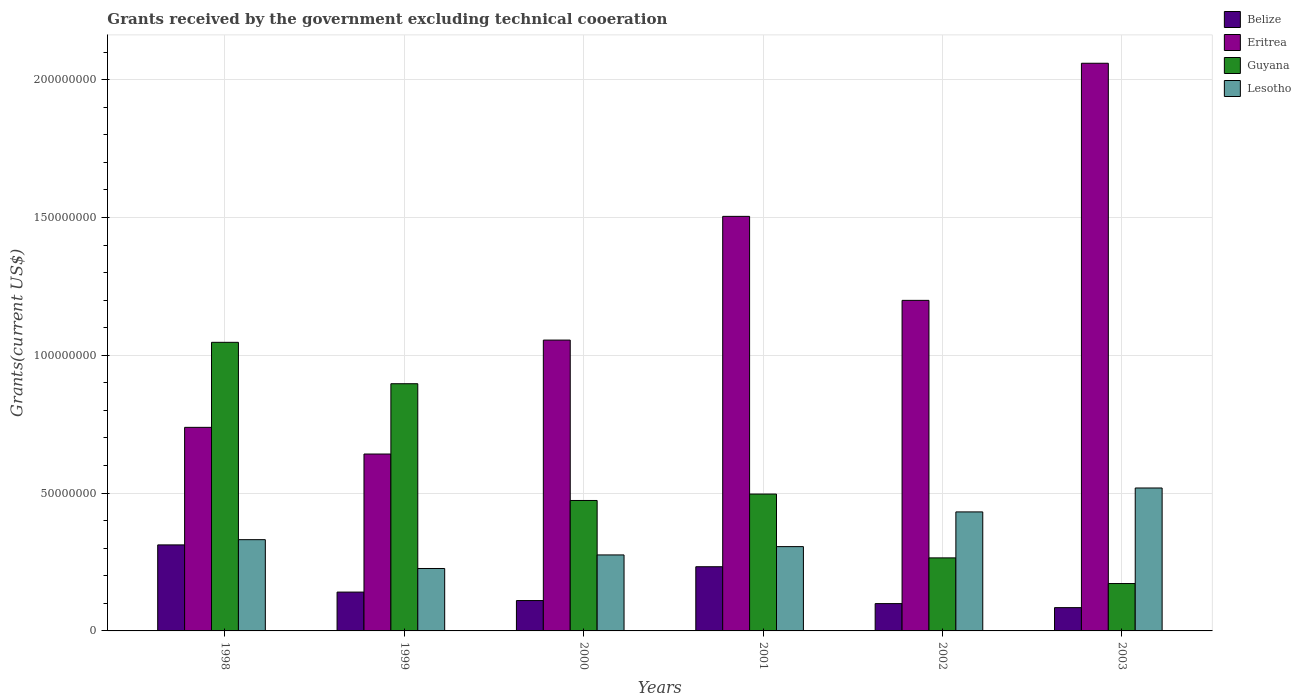Are the number of bars per tick equal to the number of legend labels?
Give a very brief answer. Yes. How many bars are there on the 5th tick from the left?
Make the answer very short. 4. What is the total grants received by the government in Eritrea in 1998?
Make the answer very short. 7.39e+07. Across all years, what is the maximum total grants received by the government in Lesotho?
Make the answer very short. 5.19e+07. Across all years, what is the minimum total grants received by the government in Belize?
Ensure brevity in your answer.  8.45e+06. In which year was the total grants received by the government in Guyana minimum?
Make the answer very short. 2003. What is the total total grants received by the government in Guyana in the graph?
Your response must be concise. 3.35e+08. What is the difference between the total grants received by the government in Belize in 2000 and that in 2002?
Make the answer very short. 1.11e+06. What is the difference between the total grants received by the government in Eritrea in 1998 and the total grants received by the government in Lesotho in 2002?
Your answer should be compact. 3.07e+07. What is the average total grants received by the government in Lesotho per year?
Keep it short and to the point. 3.48e+07. In the year 1998, what is the difference between the total grants received by the government in Guyana and total grants received by the government in Belize?
Keep it short and to the point. 7.35e+07. What is the ratio of the total grants received by the government in Belize in 2001 to that in 2003?
Keep it short and to the point. 2.76. Is the total grants received by the government in Belize in 2000 less than that in 2002?
Your answer should be very brief. No. Is the difference between the total grants received by the government in Guyana in 1999 and 2000 greater than the difference between the total grants received by the government in Belize in 1999 and 2000?
Keep it short and to the point. Yes. What is the difference between the highest and the second highest total grants received by the government in Guyana?
Offer a terse response. 1.50e+07. What is the difference between the highest and the lowest total grants received by the government in Lesotho?
Make the answer very short. 2.92e+07. What does the 3rd bar from the left in 1998 represents?
Offer a terse response. Guyana. What does the 2nd bar from the right in 2002 represents?
Offer a very short reply. Guyana. Are all the bars in the graph horizontal?
Keep it short and to the point. No. How many years are there in the graph?
Your answer should be very brief. 6. What is the difference between two consecutive major ticks on the Y-axis?
Your response must be concise. 5.00e+07. Does the graph contain any zero values?
Make the answer very short. No. How many legend labels are there?
Offer a very short reply. 4. How are the legend labels stacked?
Your answer should be compact. Vertical. What is the title of the graph?
Ensure brevity in your answer.  Grants received by the government excluding technical cooeration. What is the label or title of the X-axis?
Your answer should be very brief. Years. What is the label or title of the Y-axis?
Give a very brief answer. Grants(current US$). What is the Grants(current US$) in Belize in 1998?
Your answer should be compact. 3.12e+07. What is the Grants(current US$) in Eritrea in 1998?
Your response must be concise. 7.39e+07. What is the Grants(current US$) of Guyana in 1998?
Ensure brevity in your answer.  1.05e+08. What is the Grants(current US$) of Lesotho in 1998?
Offer a terse response. 3.31e+07. What is the Grants(current US$) in Belize in 1999?
Offer a very short reply. 1.41e+07. What is the Grants(current US$) in Eritrea in 1999?
Your response must be concise. 6.42e+07. What is the Grants(current US$) of Guyana in 1999?
Offer a terse response. 8.97e+07. What is the Grants(current US$) of Lesotho in 1999?
Keep it short and to the point. 2.26e+07. What is the Grants(current US$) of Belize in 2000?
Make the answer very short. 1.10e+07. What is the Grants(current US$) of Eritrea in 2000?
Your answer should be very brief. 1.06e+08. What is the Grants(current US$) in Guyana in 2000?
Give a very brief answer. 4.73e+07. What is the Grants(current US$) of Lesotho in 2000?
Offer a very short reply. 2.76e+07. What is the Grants(current US$) in Belize in 2001?
Give a very brief answer. 2.33e+07. What is the Grants(current US$) in Eritrea in 2001?
Provide a short and direct response. 1.50e+08. What is the Grants(current US$) of Guyana in 2001?
Give a very brief answer. 4.97e+07. What is the Grants(current US$) in Lesotho in 2001?
Give a very brief answer. 3.06e+07. What is the Grants(current US$) in Belize in 2002?
Provide a short and direct response. 9.91e+06. What is the Grants(current US$) in Eritrea in 2002?
Provide a succinct answer. 1.20e+08. What is the Grants(current US$) in Guyana in 2002?
Your response must be concise. 2.65e+07. What is the Grants(current US$) of Lesotho in 2002?
Offer a terse response. 4.32e+07. What is the Grants(current US$) of Belize in 2003?
Your answer should be very brief. 8.45e+06. What is the Grants(current US$) of Eritrea in 2003?
Provide a succinct answer. 2.06e+08. What is the Grants(current US$) in Guyana in 2003?
Your answer should be compact. 1.72e+07. What is the Grants(current US$) of Lesotho in 2003?
Make the answer very short. 5.19e+07. Across all years, what is the maximum Grants(current US$) of Belize?
Offer a terse response. 3.12e+07. Across all years, what is the maximum Grants(current US$) in Eritrea?
Give a very brief answer. 2.06e+08. Across all years, what is the maximum Grants(current US$) in Guyana?
Ensure brevity in your answer.  1.05e+08. Across all years, what is the maximum Grants(current US$) of Lesotho?
Ensure brevity in your answer.  5.19e+07. Across all years, what is the minimum Grants(current US$) in Belize?
Give a very brief answer. 8.45e+06. Across all years, what is the minimum Grants(current US$) of Eritrea?
Your response must be concise. 6.42e+07. Across all years, what is the minimum Grants(current US$) of Guyana?
Give a very brief answer. 1.72e+07. Across all years, what is the minimum Grants(current US$) in Lesotho?
Provide a short and direct response. 2.26e+07. What is the total Grants(current US$) of Belize in the graph?
Your answer should be very brief. 9.80e+07. What is the total Grants(current US$) in Eritrea in the graph?
Your answer should be compact. 7.20e+08. What is the total Grants(current US$) in Guyana in the graph?
Keep it short and to the point. 3.35e+08. What is the total Grants(current US$) in Lesotho in the graph?
Offer a very short reply. 2.09e+08. What is the difference between the Grants(current US$) in Belize in 1998 and that in 1999?
Make the answer very short. 1.71e+07. What is the difference between the Grants(current US$) of Eritrea in 1998 and that in 1999?
Make the answer very short. 9.68e+06. What is the difference between the Grants(current US$) in Guyana in 1998 and that in 1999?
Provide a succinct answer. 1.50e+07. What is the difference between the Grants(current US$) in Lesotho in 1998 and that in 1999?
Keep it short and to the point. 1.05e+07. What is the difference between the Grants(current US$) in Belize in 1998 and that in 2000?
Provide a succinct answer. 2.02e+07. What is the difference between the Grants(current US$) of Eritrea in 1998 and that in 2000?
Provide a succinct answer. -3.17e+07. What is the difference between the Grants(current US$) in Guyana in 1998 and that in 2000?
Give a very brief answer. 5.74e+07. What is the difference between the Grants(current US$) of Lesotho in 1998 and that in 2000?
Offer a very short reply. 5.54e+06. What is the difference between the Grants(current US$) in Belize in 1998 and that in 2001?
Offer a very short reply. 7.92e+06. What is the difference between the Grants(current US$) in Eritrea in 1998 and that in 2001?
Provide a succinct answer. -7.66e+07. What is the difference between the Grants(current US$) in Guyana in 1998 and that in 2001?
Ensure brevity in your answer.  5.50e+07. What is the difference between the Grants(current US$) of Lesotho in 1998 and that in 2001?
Your response must be concise. 2.52e+06. What is the difference between the Grants(current US$) in Belize in 1998 and that in 2002?
Offer a very short reply. 2.13e+07. What is the difference between the Grants(current US$) of Eritrea in 1998 and that in 2002?
Offer a very short reply. -4.61e+07. What is the difference between the Grants(current US$) in Guyana in 1998 and that in 2002?
Your answer should be compact. 7.82e+07. What is the difference between the Grants(current US$) of Lesotho in 1998 and that in 2002?
Keep it short and to the point. -1.01e+07. What is the difference between the Grants(current US$) in Belize in 1998 and that in 2003?
Give a very brief answer. 2.28e+07. What is the difference between the Grants(current US$) in Eritrea in 1998 and that in 2003?
Provide a succinct answer. -1.32e+08. What is the difference between the Grants(current US$) in Guyana in 1998 and that in 2003?
Ensure brevity in your answer.  8.75e+07. What is the difference between the Grants(current US$) in Lesotho in 1998 and that in 2003?
Offer a very short reply. -1.88e+07. What is the difference between the Grants(current US$) of Belize in 1999 and that in 2000?
Provide a succinct answer. 3.07e+06. What is the difference between the Grants(current US$) in Eritrea in 1999 and that in 2000?
Provide a succinct answer. -4.13e+07. What is the difference between the Grants(current US$) of Guyana in 1999 and that in 2000?
Give a very brief answer. 4.24e+07. What is the difference between the Grants(current US$) in Lesotho in 1999 and that in 2000?
Offer a very short reply. -4.92e+06. What is the difference between the Grants(current US$) of Belize in 1999 and that in 2001?
Offer a very short reply. -9.20e+06. What is the difference between the Grants(current US$) in Eritrea in 1999 and that in 2001?
Keep it short and to the point. -8.62e+07. What is the difference between the Grants(current US$) in Guyana in 1999 and that in 2001?
Offer a terse response. 4.00e+07. What is the difference between the Grants(current US$) of Lesotho in 1999 and that in 2001?
Give a very brief answer. -7.94e+06. What is the difference between the Grants(current US$) in Belize in 1999 and that in 2002?
Keep it short and to the point. 4.18e+06. What is the difference between the Grants(current US$) in Eritrea in 1999 and that in 2002?
Make the answer very short. -5.58e+07. What is the difference between the Grants(current US$) of Guyana in 1999 and that in 2002?
Provide a short and direct response. 6.32e+07. What is the difference between the Grants(current US$) in Lesotho in 1999 and that in 2002?
Ensure brevity in your answer.  -2.05e+07. What is the difference between the Grants(current US$) of Belize in 1999 and that in 2003?
Give a very brief answer. 5.64e+06. What is the difference between the Grants(current US$) of Eritrea in 1999 and that in 2003?
Keep it short and to the point. -1.42e+08. What is the difference between the Grants(current US$) in Guyana in 1999 and that in 2003?
Keep it short and to the point. 7.25e+07. What is the difference between the Grants(current US$) of Lesotho in 1999 and that in 2003?
Give a very brief answer. -2.92e+07. What is the difference between the Grants(current US$) in Belize in 2000 and that in 2001?
Make the answer very short. -1.23e+07. What is the difference between the Grants(current US$) in Eritrea in 2000 and that in 2001?
Offer a terse response. -4.49e+07. What is the difference between the Grants(current US$) of Guyana in 2000 and that in 2001?
Keep it short and to the point. -2.33e+06. What is the difference between the Grants(current US$) of Lesotho in 2000 and that in 2001?
Offer a terse response. -3.02e+06. What is the difference between the Grants(current US$) of Belize in 2000 and that in 2002?
Make the answer very short. 1.11e+06. What is the difference between the Grants(current US$) of Eritrea in 2000 and that in 2002?
Provide a short and direct response. -1.44e+07. What is the difference between the Grants(current US$) in Guyana in 2000 and that in 2002?
Your response must be concise. 2.08e+07. What is the difference between the Grants(current US$) of Lesotho in 2000 and that in 2002?
Keep it short and to the point. -1.56e+07. What is the difference between the Grants(current US$) in Belize in 2000 and that in 2003?
Provide a short and direct response. 2.57e+06. What is the difference between the Grants(current US$) of Eritrea in 2000 and that in 2003?
Give a very brief answer. -1.00e+08. What is the difference between the Grants(current US$) in Guyana in 2000 and that in 2003?
Your response must be concise. 3.01e+07. What is the difference between the Grants(current US$) in Lesotho in 2000 and that in 2003?
Your answer should be compact. -2.43e+07. What is the difference between the Grants(current US$) of Belize in 2001 and that in 2002?
Ensure brevity in your answer.  1.34e+07. What is the difference between the Grants(current US$) of Eritrea in 2001 and that in 2002?
Make the answer very short. 3.05e+07. What is the difference between the Grants(current US$) in Guyana in 2001 and that in 2002?
Ensure brevity in your answer.  2.32e+07. What is the difference between the Grants(current US$) in Lesotho in 2001 and that in 2002?
Provide a short and direct response. -1.26e+07. What is the difference between the Grants(current US$) in Belize in 2001 and that in 2003?
Make the answer very short. 1.48e+07. What is the difference between the Grants(current US$) in Eritrea in 2001 and that in 2003?
Your response must be concise. -5.56e+07. What is the difference between the Grants(current US$) of Guyana in 2001 and that in 2003?
Ensure brevity in your answer.  3.25e+07. What is the difference between the Grants(current US$) of Lesotho in 2001 and that in 2003?
Give a very brief answer. -2.13e+07. What is the difference between the Grants(current US$) of Belize in 2002 and that in 2003?
Your answer should be very brief. 1.46e+06. What is the difference between the Grants(current US$) of Eritrea in 2002 and that in 2003?
Your answer should be compact. -8.60e+07. What is the difference between the Grants(current US$) in Guyana in 2002 and that in 2003?
Your response must be concise. 9.31e+06. What is the difference between the Grants(current US$) of Lesotho in 2002 and that in 2003?
Keep it short and to the point. -8.68e+06. What is the difference between the Grants(current US$) in Belize in 1998 and the Grants(current US$) in Eritrea in 1999?
Your answer should be compact. -3.30e+07. What is the difference between the Grants(current US$) of Belize in 1998 and the Grants(current US$) of Guyana in 1999?
Offer a very short reply. -5.85e+07. What is the difference between the Grants(current US$) of Belize in 1998 and the Grants(current US$) of Lesotho in 1999?
Your response must be concise. 8.56e+06. What is the difference between the Grants(current US$) of Eritrea in 1998 and the Grants(current US$) of Guyana in 1999?
Your answer should be very brief. -1.58e+07. What is the difference between the Grants(current US$) of Eritrea in 1998 and the Grants(current US$) of Lesotho in 1999?
Keep it short and to the point. 5.12e+07. What is the difference between the Grants(current US$) of Guyana in 1998 and the Grants(current US$) of Lesotho in 1999?
Ensure brevity in your answer.  8.21e+07. What is the difference between the Grants(current US$) in Belize in 1998 and the Grants(current US$) in Eritrea in 2000?
Provide a succinct answer. -7.43e+07. What is the difference between the Grants(current US$) in Belize in 1998 and the Grants(current US$) in Guyana in 2000?
Provide a succinct answer. -1.61e+07. What is the difference between the Grants(current US$) in Belize in 1998 and the Grants(current US$) in Lesotho in 2000?
Make the answer very short. 3.64e+06. What is the difference between the Grants(current US$) of Eritrea in 1998 and the Grants(current US$) of Guyana in 2000?
Your response must be concise. 2.65e+07. What is the difference between the Grants(current US$) in Eritrea in 1998 and the Grants(current US$) in Lesotho in 2000?
Provide a succinct answer. 4.63e+07. What is the difference between the Grants(current US$) of Guyana in 1998 and the Grants(current US$) of Lesotho in 2000?
Offer a terse response. 7.71e+07. What is the difference between the Grants(current US$) of Belize in 1998 and the Grants(current US$) of Eritrea in 2001?
Provide a short and direct response. -1.19e+08. What is the difference between the Grants(current US$) in Belize in 1998 and the Grants(current US$) in Guyana in 2001?
Give a very brief answer. -1.84e+07. What is the difference between the Grants(current US$) in Belize in 1998 and the Grants(current US$) in Lesotho in 2001?
Provide a succinct answer. 6.20e+05. What is the difference between the Grants(current US$) in Eritrea in 1998 and the Grants(current US$) in Guyana in 2001?
Provide a succinct answer. 2.42e+07. What is the difference between the Grants(current US$) of Eritrea in 1998 and the Grants(current US$) of Lesotho in 2001?
Give a very brief answer. 4.33e+07. What is the difference between the Grants(current US$) in Guyana in 1998 and the Grants(current US$) in Lesotho in 2001?
Provide a short and direct response. 7.41e+07. What is the difference between the Grants(current US$) in Belize in 1998 and the Grants(current US$) in Eritrea in 2002?
Keep it short and to the point. -8.87e+07. What is the difference between the Grants(current US$) in Belize in 1998 and the Grants(current US$) in Guyana in 2002?
Your answer should be very brief. 4.71e+06. What is the difference between the Grants(current US$) of Belize in 1998 and the Grants(current US$) of Lesotho in 2002?
Your answer should be compact. -1.20e+07. What is the difference between the Grants(current US$) in Eritrea in 1998 and the Grants(current US$) in Guyana in 2002?
Keep it short and to the point. 4.74e+07. What is the difference between the Grants(current US$) of Eritrea in 1998 and the Grants(current US$) of Lesotho in 2002?
Provide a succinct answer. 3.07e+07. What is the difference between the Grants(current US$) in Guyana in 1998 and the Grants(current US$) in Lesotho in 2002?
Your response must be concise. 6.15e+07. What is the difference between the Grants(current US$) in Belize in 1998 and the Grants(current US$) in Eritrea in 2003?
Keep it short and to the point. -1.75e+08. What is the difference between the Grants(current US$) of Belize in 1998 and the Grants(current US$) of Guyana in 2003?
Make the answer very short. 1.40e+07. What is the difference between the Grants(current US$) in Belize in 1998 and the Grants(current US$) in Lesotho in 2003?
Your answer should be very brief. -2.06e+07. What is the difference between the Grants(current US$) in Eritrea in 1998 and the Grants(current US$) in Guyana in 2003?
Offer a very short reply. 5.67e+07. What is the difference between the Grants(current US$) in Eritrea in 1998 and the Grants(current US$) in Lesotho in 2003?
Make the answer very short. 2.20e+07. What is the difference between the Grants(current US$) of Guyana in 1998 and the Grants(current US$) of Lesotho in 2003?
Your answer should be compact. 5.28e+07. What is the difference between the Grants(current US$) in Belize in 1999 and the Grants(current US$) in Eritrea in 2000?
Your answer should be compact. -9.14e+07. What is the difference between the Grants(current US$) of Belize in 1999 and the Grants(current US$) of Guyana in 2000?
Ensure brevity in your answer.  -3.32e+07. What is the difference between the Grants(current US$) in Belize in 1999 and the Grants(current US$) in Lesotho in 2000?
Offer a terse response. -1.35e+07. What is the difference between the Grants(current US$) in Eritrea in 1999 and the Grants(current US$) in Guyana in 2000?
Your answer should be very brief. 1.68e+07. What is the difference between the Grants(current US$) of Eritrea in 1999 and the Grants(current US$) of Lesotho in 2000?
Provide a succinct answer. 3.66e+07. What is the difference between the Grants(current US$) of Guyana in 1999 and the Grants(current US$) of Lesotho in 2000?
Your answer should be compact. 6.21e+07. What is the difference between the Grants(current US$) of Belize in 1999 and the Grants(current US$) of Eritrea in 2001?
Provide a short and direct response. -1.36e+08. What is the difference between the Grants(current US$) in Belize in 1999 and the Grants(current US$) in Guyana in 2001?
Your answer should be compact. -3.56e+07. What is the difference between the Grants(current US$) in Belize in 1999 and the Grants(current US$) in Lesotho in 2001?
Offer a terse response. -1.65e+07. What is the difference between the Grants(current US$) of Eritrea in 1999 and the Grants(current US$) of Guyana in 2001?
Provide a short and direct response. 1.45e+07. What is the difference between the Grants(current US$) of Eritrea in 1999 and the Grants(current US$) of Lesotho in 2001?
Provide a succinct answer. 3.36e+07. What is the difference between the Grants(current US$) in Guyana in 1999 and the Grants(current US$) in Lesotho in 2001?
Offer a terse response. 5.91e+07. What is the difference between the Grants(current US$) in Belize in 1999 and the Grants(current US$) in Eritrea in 2002?
Provide a short and direct response. -1.06e+08. What is the difference between the Grants(current US$) in Belize in 1999 and the Grants(current US$) in Guyana in 2002?
Provide a short and direct response. -1.24e+07. What is the difference between the Grants(current US$) in Belize in 1999 and the Grants(current US$) in Lesotho in 2002?
Give a very brief answer. -2.91e+07. What is the difference between the Grants(current US$) of Eritrea in 1999 and the Grants(current US$) of Guyana in 2002?
Provide a succinct answer. 3.77e+07. What is the difference between the Grants(current US$) in Eritrea in 1999 and the Grants(current US$) in Lesotho in 2002?
Keep it short and to the point. 2.10e+07. What is the difference between the Grants(current US$) in Guyana in 1999 and the Grants(current US$) in Lesotho in 2002?
Keep it short and to the point. 4.65e+07. What is the difference between the Grants(current US$) of Belize in 1999 and the Grants(current US$) of Eritrea in 2003?
Keep it short and to the point. -1.92e+08. What is the difference between the Grants(current US$) in Belize in 1999 and the Grants(current US$) in Guyana in 2003?
Keep it short and to the point. -3.10e+06. What is the difference between the Grants(current US$) in Belize in 1999 and the Grants(current US$) in Lesotho in 2003?
Give a very brief answer. -3.78e+07. What is the difference between the Grants(current US$) of Eritrea in 1999 and the Grants(current US$) of Guyana in 2003?
Provide a succinct answer. 4.70e+07. What is the difference between the Grants(current US$) of Eritrea in 1999 and the Grants(current US$) of Lesotho in 2003?
Keep it short and to the point. 1.23e+07. What is the difference between the Grants(current US$) of Guyana in 1999 and the Grants(current US$) of Lesotho in 2003?
Your response must be concise. 3.78e+07. What is the difference between the Grants(current US$) in Belize in 2000 and the Grants(current US$) in Eritrea in 2001?
Your answer should be compact. -1.39e+08. What is the difference between the Grants(current US$) in Belize in 2000 and the Grants(current US$) in Guyana in 2001?
Make the answer very short. -3.86e+07. What is the difference between the Grants(current US$) in Belize in 2000 and the Grants(current US$) in Lesotho in 2001?
Ensure brevity in your answer.  -1.96e+07. What is the difference between the Grants(current US$) in Eritrea in 2000 and the Grants(current US$) in Guyana in 2001?
Offer a terse response. 5.59e+07. What is the difference between the Grants(current US$) of Eritrea in 2000 and the Grants(current US$) of Lesotho in 2001?
Provide a short and direct response. 7.49e+07. What is the difference between the Grants(current US$) of Guyana in 2000 and the Grants(current US$) of Lesotho in 2001?
Offer a very short reply. 1.67e+07. What is the difference between the Grants(current US$) in Belize in 2000 and the Grants(current US$) in Eritrea in 2002?
Provide a succinct answer. -1.09e+08. What is the difference between the Grants(current US$) in Belize in 2000 and the Grants(current US$) in Guyana in 2002?
Your response must be concise. -1.55e+07. What is the difference between the Grants(current US$) of Belize in 2000 and the Grants(current US$) of Lesotho in 2002?
Provide a short and direct response. -3.22e+07. What is the difference between the Grants(current US$) in Eritrea in 2000 and the Grants(current US$) in Guyana in 2002?
Provide a succinct answer. 7.90e+07. What is the difference between the Grants(current US$) of Eritrea in 2000 and the Grants(current US$) of Lesotho in 2002?
Offer a very short reply. 6.23e+07. What is the difference between the Grants(current US$) in Guyana in 2000 and the Grants(current US$) in Lesotho in 2002?
Keep it short and to the point. 4.15e+06. What is the difference between the Grants(current US$) in Belize in 2000 and the Grants(current US$) in Eritrea in 2003?
Offer a terse response. -1.95e+08. What is the difference between the Grants(current US$) in Belize in 2000 and the Grants(current US$) in Guyana in 2003?
Ensure brevity in your answer.  -6.17e+06. What is the difference between the Grants(current US$) in Belize in 2000 and the Grants(current US$) in Lesotho in 2003?
Offer a very short reply. -4.08e+07. What is the difference between the Grants(current US$) of Eritrea in 2000 and the Grants(current US$) of Guyana in 2003?
Provide a succinct answer. 8.83e+07. What is the difference between the Grants(current US$) of Eritrea in 2000 and the Grants(current US$) of Lesotho in 2003?
Provide a succinct answer. 5.37e+07. What is the difference between the Grants(current US$) of Guyana in 2000 and the Grants(current US$) of Lesotho in 2003?
Offer a very short reply. -4.53e+06. What is the difference between the Grants(current US$) in Belize in 2001 and the Grants(current US$) in Eritrea in 2002?
Provide a succinct answer. -9.66e+07. What is the difference between the Grants(current US$) in Belize in 2001 and the Grants(current US$) in Guyana in 2002?
Ensure brevity in your answer.  -3.21e+06. What is the difference between the Grants(current US$) in Belize in 2001 and the Grants(current US$) in Lesotho in 2002?
Offer a terse response. -1.99e+07. What is the difference between the Grants(current US$) in Eritrea in 2001 and the Grants(current US$) in Guyana in 2002?
Ensure brevity in your answer.  1.24e+08. What is the difference between the Grants(current US$) in Eritrea in 2001 and the Grants(current US$) in Lesotho in 2002?
Offer a very short reply. 1.07e+08. What is the difference between the Grants(current US$) in Guyana in 2001 and the Grants(current US$) in Lesotho in 2002?
Your answer should be very brief. 6.48e+06. What is the difference between the Grants(current US$) of Belize in 2001 and the Grants(current US$) of Eritrea in 2003?
Your answer should be compact. -1.83e+08. What is the difference between the Grants(current US$) of Belize in 2001 and the Grants(current US$) of Guyana in 2003?
Give a very brief answer. 6.10e+06. What is the difference between the Grants(current US$) in Belize in 2001 and the Grants(current US$) in Lesotho in 2003?
Make the answer very short. -2.86e+07. What is the difference between the Grants(current US$) in Eritrea in 2001 and the Grants(current US$) in Guyana in 2003?
Offer a very short reply. 1.33e+08. What is the difference between the Grants(current US$) of Eritrea in 2001 and the Grants(current US$) of Lesotho in 2003?
Ensure brevity in your answer.  9.86e+07. What is the difference between the Grants(current US$) in Guyana in 2001 and the Grants(current US$) in Lesotho in 2003?
Provide a succinct answer. -2.20e+06. What is the difference between the Grants(current US$) in Belize in 2002 and the Grants(current US$) in Eritrea in 2003?
Your answer should be very brief. -1.96e+08. What is the difference between the Grants(current US$) in Belize in 2002 and the Grants(current US$) in Guyana in 2003?
Provide a succinct answer. -7.28e+06. What is the difference between the Grants(current US$) of Belize in 2002 and the Grants(current US$) of Lesotho in 2003?
Offer a very short reply. -4.20e+07. What is the difference between the Grants(current US$) in Eritrea in 2002 and the Grants(current US$) in Guyana in 2003?
Offer a very short reply. 1.03e+08. What is the difference between the Grants(current US$) in Eritrea in 2002 and the Grants(current US$) in Lesotho in 2003?
Your answer should be very brief. 6.81e+07. What is the difference between the Grants(current US$) in Guyana in 2002 and the Grants(current US$) in Lesotho in 2003?
Your response must be concise. -2.54e+07. What is the average Grants(current US$) in Belize per year?
Give a very brief answer. 1.63e+07. What is the average Grants(current US$) of Eritrea per year?
Keep it short and to the point. 1.20e+08. What is the average Grants(current US$) of Guyana per year?
Your response must be concise. 5.58e+07. What is the average Grants(current US$) of Lesotho per year?
Your answer should be very brief. 3.48e+07. In the year 1998, what is the difference between the Grants(current US$) of Belize and Grants(current US$) of Eritrea?
Give a very brief answer. -4.26e+07. In the year 1998, what is the difference between the Grants(current US$) of Belize and Grants(current US$) of Guyana?
Your response must be concise. -7.35e+07. In the year 1998, what is the difference between the Grants(current US$) of Belize and Grants(current US$) of Lesotho?
Offer a very short reply. -1.90e+06. In the year 1998, what is the difference between the Grants(current US$) in Eritrea and Grants(current US$) in Guyana?
Your answer should be very brief. -3.08e+07. In the year 1998, what is the difference between the Grants(current US$) of Eritrea and Grants(current US$) of Lesotho?
Provide a short and direct response. 4.08e+07. In the year 1998, what is the difference between the Grants(current US$) of Guyana and Grants(current US$) of Lesotho?
Your answer should be compact. 7.16e+07. In the year 1999, what is the difference between the Grants(current US$) of Belize and Grants(current US$) of Eritrea?
Your response must be concise. -5.01e+07. In the year 1999, what is the difference between the Grants(current US$) in Belize and Grants(current US$) in Guyana?
Keep it short and to the point. -7.56e+07. In the year 1999, what is the difference between the Grants(current US$) of Belize and Grants(current US$) of Lesotho?
Ensure brevity in your answer.  -8.56e+06. In the year 1999, what is the difference between the Grants(current US$) in Eritrea and Grants(current US$) in Guyana?
Make the answer very short. -2.55e+07. In the year 1999, what is the difference between the Grants(current US$) of Eritrea and Grants(current US$) of Lesotho?
Make the answer very short. 4.15e+07. In the year 1999, what is the difference between the Grants(current US$) in Guyana and Grants(current US$) in Lesotho?
Give a very brief answer. 6.70e+07. In the year 2000, what is the difference between the Grants(current US$) of Belize and Grants(current US$) of Eritrea?
Ensure brevity in your answer.  -9.45e+07. In the year 2000, what is the difference between the Grants(current US$) in Belize and Grants(current US$) in Guyana?
Offer a very short reply. -3.63e+07. In the year 2000, what is the difference between the Grants(current US$) in Belize and Grants(current US$) in Lesotho?
Make the answer very short. -1.66e+07. In the year 2000, what is the difference between the Grants(current US$) of Eritrea and Grants(current US$) of Guyana?
Ensure brevity in your answer.  5.82e+07. In the year 2000, what is the difference between the Grants(current US$) of Eritrea and Grants(current US$) of Lesotho?
Provide a succinct answer. 7.80e+07. In the year 2000, what is the difference between the Grants(current US$) in Guyana and Grants(current US$) in Lesotho?
Provide a succinct answer. 1.98e+07. In the year 2001, what is the difference between the Grants(current US$) in Belize and Grants(current US$) in Eritrea?
Give a very brief answer. -1.27e+08. In the year 2001, what is the difference between the Grants(current US$) of Belize and Grants(current US$) of Guyana?
Your answer should be compact. -2.64e+07. In the year 2001, what is the difference between the Grants(current US$) of Belize and Grants(current US$) of Lesotho?
Make the answer very short. -7.30e+06. In the year 2001, what is the difference between the Grants(current US$) in Eritrea and Grants(current US$) in Guyana?
Make the answer very short. 1.01e+08. In the year 2001, what is the difference between the Grants(current US$) in Eritrea and Grants(current US$) in Lesotho?
Provide a short and direct response. 1.20e+08. In the year 2001, what is the difference between the Grants(current US$) in Guyana and Grants(current US$) in Lesotho?
Provide a short and direct response. 1.91e+07. In the year 2002, what is the difference between the Grants(current US$) in Belize and Grants(current US$) in Eritrea?
Provide a short and direct response. -1.10e+08. In the year 2002, what is the difference between the Grants(current US$) of Belize and Grants(current US$) of Guyana?
Provide a succinct answer. -1.66e+07. In the year 2002, what is the difference between the Grants(current US$) in Belize and Grants(current US$) in Lesotho?
Your response must be concise. -3.33e+07. In the year 2002, what is the difference between the Grants(current US$) in Eritrea and Grants(current US$) in Guyana?
Provide a short and direct response. 9.34e+07. In the year 2002, what is the difference between the Grants(current US$) in Eritrea and Grants(current US$) in Lesotho?
Your response must be concise. 7.68e+07. In the year 2002, what is the difference between the Grants(current US$) of Guyana and Grants(current US$) of Lesotho?
Provide a succinct answer. -1.67e+07. In the year 2003, what is the difference between the Grants(current US$) of Belize and Grants(current US$) of Eritrea?
Provide a short and direct response. -1.98e+08. In the year 2003, what is the difference between the Grants(current US$) in Belize and Grants(current US$) in Guyana?
Make the answer very short. -8.74e+06. In the year 2003, what is the difference between the Grants(current US$) of Belize and Grants(current US$) of Lesotho?
Provide a succinct answer. -4.34e+07. In the year 2003, what is the difference between the Grants(current US$) of Eritrea and Grants(current US$) of Guyana?
Give a very brief answer. 1.89e+08. In the year 2003, what is the difference between the Grants(current US$) of Eritrea and Grants(current US$) of Lesotho?
Your answer should be very brief. 1.54e+08. In the year 2003, what is the difference between the Grants(current US$) in Guyana and Grants(current US$) in Lesotho?
Provide a succinct answer. -3.47e+07. What is the ratio of the Grants(current US$) of Belize in 1998 to that in 1999?
Make the answer very short. 2.21. What is the ratio of the Grants(current US$) in Eritrea in 1998 to that in 1999?
Offer a very short reply. 1.15. What is the ratio of the Grants(current US$) of Guyana in 1998 to that in 1999?
Keep it short and to the point. 1.17. What is the ratio of the Grants(current US$) of Lesotho in 1998 to that in 1999?
Provide a short and direct response. 1.46. What is the ratio of the Grants(current US$) in Belize in 1998 to that in 2000?
Keep it short and to the point. 2.83. What is the ratio of the Grants(current US$) in Guyana in 1998 to that in 2000?
Provide a succinct answer. 2.21. What is the ratio of the Grants(current US$) in Lesotho in 1998 to that in 2000?
Ensure brevity in your answer.  1.2. What is the ratio of the Grants(current US$) in Belize in 1998 to that in 2001?
Your answer should be compact. 1.34. What is the ratio of the Grants(current US$) of Eritrea in 1998 to that in 2001?
Offer a terse response. 0.49. What is the ratio of the Grants(current US$) of Guyana in 1998 to that in 2001?
Provide a short and direct response. 2.11. What is the ratio of the Grants(current US$) in Lesotho in 1998 to that in 2001?
Offer a very short reply. 1.08. What is the ratio of the Grants(current US$) of Belize in 1998 to that in 2002?
Keep it short and to the point. 3.15. What is the ratio of the Grants(current US$) in Eritrea in 1998 to that in 2002?
Your answer should be very brief. 0.62. What is the ratio of the Grants(current US$) in Guyana in 1998 to that in 2002?
Make the answer very short. 3.95. What is the ratio of the Grants(current US$) of Lesotho in 1998 to that in 2002?
Offer a terse response. 0.77. What is the ratio of the Grants(current US$) of Belize in 1998 to that in 2003?
Your response must be concise. 3.69. What is the ratio of the Grants(current US$) of Eritrea in 1998 to that in 2003?
Keep it short and to the point. 0.36. What is the ratio of the Grants(current US$) of Guyana in 1998 to that in 2003?
Provide a short and direct response. 6.09. What is the ratio of the Grants(current US$) of Lesotho in 1998 to that in 2003?
Provide a succinct answer. 0.64. What is the ratio of the Grants(current US$) in Belize in 1999 to that in 2000?
Offer a very short reply. 1.28. What is the ratio of the Grants(current US$) in Eritrea in 1999 to that in 2000?
Make the answer very short. 0.61. What is the ratio of the Grants(current US$) in Guyana in 1999 to that in 2000?
Keep it short and to the point. 1.9. What is the ratio of the Grants(current US$) of Lesotho in 1999 to that in 2000?
Keep it short and to the point. 0.82. What is the ratio of the Grants(current US$) of Belize in 1999 to that in 2001?
Ensure brevity in your answer.  0.6. What is the ratio of the Grants(current US$) in Eritrea in 1999 to that in 2001?
Provide a short and direct response. 0.43. What is the ratio of the Grants(current US$) of Guyana in 1999 to that in 2001?
Provide a short and direct response. 1.81. What is the ratio of the Grants(current US$) in Lesotho in 1999 to that in 2001?
Offer a terse response. 0.74. What is the ratio of the Grants(current US$) of Belize in 1999 to that in 2002?
Keep it short and to the point. 1.42. What is the ratio of the Grants(current US$) of Eritrea in 1999 to that in 2002?
Offer a very short reply. 0.54. What is the ratio of the Grants(current US$) of Guyana in 1999 to that in 2002?
Your response must be concise. 3.38. What is the ratio of the Grants(current US$) of Lesotho in 1999 to that in 2002?
Your answer should be compact. 0.52. What is the ratio of the Grants(current US$) in Belize in 1999 to that in 2003?
Your response must be concise. 1.67. What is the ratio of the Grants(current US$) of Eritrea in 1999 to that in 2003?
Ensure brevity in your answer.  0.31. What is the ratio of the Grants(current US$) in Guyana in 1999 to that in 2003?
Offer a terse response. 5.22. What is the ratio of the Grants(current US$) of Lesotho in 1999 to that in 2003?
Ensure brevity in your answer.  0.44. What is the ratio of the Grants(current US$) of Belize in 2000 to that in 2001?
Provide a succinct answer. 0.47. What is the ratio of the Grants(current US$) of Eritrea in 2000 to that in 2001?
Your answer should be very brief. 0.7. What is the ratio of the Grants(current US$) in Guyana in 2000 to that in 2001?
Give a very brief answer. 0.95. What is the ratio of the Grants(current US$) of Lesotho in 2000 to that in 2001?
Your response must be concise. 0.9. What is the ratio of the Grants(current US$) of Belize in 2000 to that in 2002?
Your answer should be very brief. 1.11. What is the ratio of the Grants(current US$) of Eritrea in 2000 to that in 2002?
Provide a succinct answer. 0.88. What is the ratio of the Grants(current US$) of Guyana in 2000 to that in 2002?
Make the answer very short. 1.79. What is the ratio of the Grants(current US$) of Lesotho in 2000 to that in 2002?
Offer a terse response. 0.64. What is the ratio of the Grants(current US$) of Belize in 2000 to that in 2003?
Give a very brief answer. 1.3. What is the ratio of the Grants(current US$) of Eritrea in 2000 to that in 2003?
Provide a short and direct response. 0.51. What is the ratio of the Grants(current US$) of Guyana in 2000 to that in 2003?
Provide a succinct answer. 2.75. What is the ratio of the Grants(current US$) of Lesotho in 2000 to that in 2003?
Provide a short and direct response. 0.53. What is the ratio of the Grants(current US$) of Belize in 2001 to that in 2002?
Offer a terse response. 2.35. What is the ratio of the Grants(current US$) of Eritrea in 2001 to that in 2002?
Your response must be concise. 1.25. What is the ratio of the Grants(current US$) of Guyana in 2001 to that in 2002?
Provide a succinct answer. 1.87. What is the ratio of the Grants(current US$) in Lesotho in 2001 to that in 2002?
Offer a terse response. 0.71. What is the ratio of the Grants(current US$) in Belize in 2001 to that in 2003?
Your answer should be very brief. 2.76. What is the ratio of the Grants(current US$) of Eritrea in 2001 to that in 2003?
Provide a succinct answer. 0.73. What is the ratio of the Grants(current US$) of Guyana in 2001 to that in 2003?
Provide a short and direct response. 2.89. What is the ratio of the Grants(current US$) in Lesotho in 2001 to that in 2003?
Keep it short and to the point. 0.59. What is the ratio of the Grants(current US$) of Belize in 2002 to that in 2003?
Make the answer very short. 1.17. What is the ratio of the Grants(current US$) of Eritrea in 2002 to that in 2003?
Provide a succinct answer. 0.58. What is the ratio of the Grants(current US$) in Guyana in 2002 to that in 2003?
Offer a very short reply. 1.54. What is the ratio of the Grants(current US$) in Lesotho in 2002 to that in 2003?
Offer a terse response. 0.83. What is the difference between the highest and the second highest Grants(current US$) in Belize?
Make the answer very short. 7.92e+06. What is the difference between the highest and the second highest Grants(current US$) of Eritrea?
Offer a terse response. 5.56e+07. What is the difference between the highest and the second highest Grants(current US$) of Guyana?
Offer a very short reply. 1.50e+07. What is the difference between the highest and the second highest Grants(current US$) of Lesotho?
Ensure brevity in your answer.  8.68e+06. What is the difference between the highest and the lowest Grants(current US$) in Belize?
Keep it short and to the point. 2.28e+07. What is the difference between the highest and the lowest Grants(current US$) in Eritrea?
Make the answer very short. 1.42e+08. What is the difference between the highest and the lowest Grants(current US$) of Guyana?
Your answer should be very brief. 8.75e+07. What is the difference between the highest and the lowest Grants(current US$) of Lesotho?
Make the answer very short. 2.92e+07. 